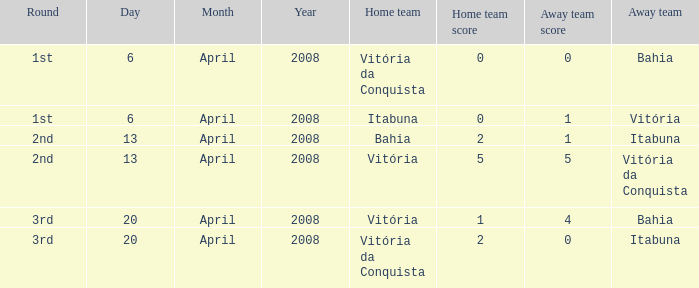Who played as the home team when Vitória was the away team? Itabuna. 